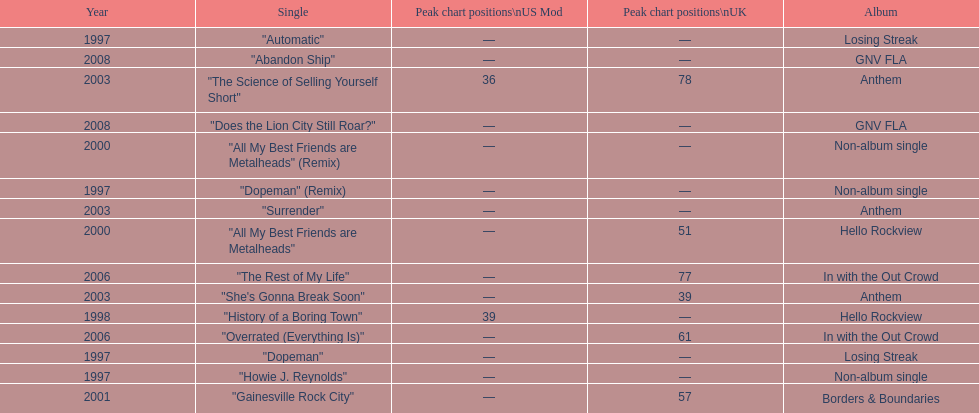Which single was released before "dopeman"? "Automatic". 